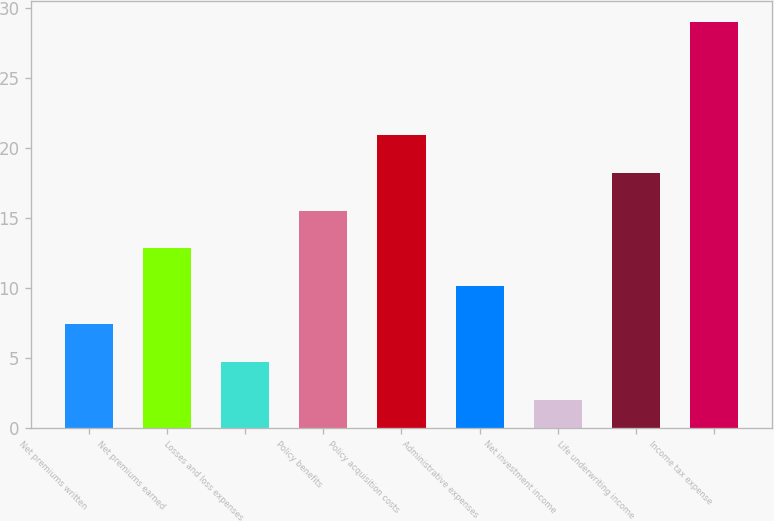Convert chart. <chart><loc_0><loc_0><loc_500><loc_500><bar_chart><fcel>Net premiums written<fcel>Net premiums earned<fcel>Losses and loss expenses<fcel>Policy benefits<fcel>Policy acquisition costs<fcel>Administrative expenses<fcel>Net investment income<fcel>Life underwriting income<fcel>Income tax expense<nl><fcel>7.4<fcel>12.8<fcel>4.7<fcel>15.5<fcel>20.9<fcel>10.1<fcel>2<fcel>18.2<fcel>29<nl></chart> 